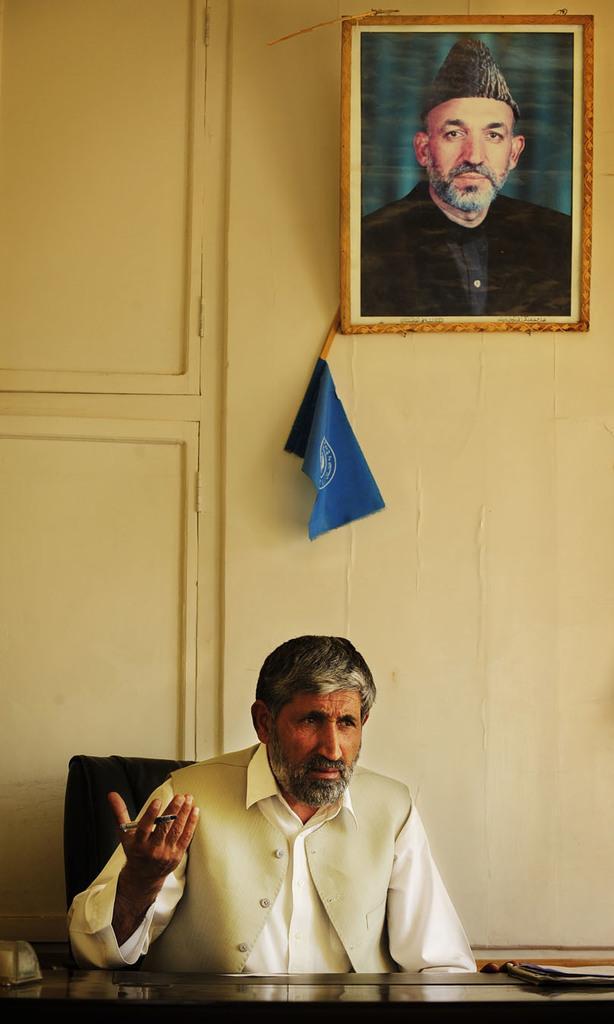Can you describe this image briefly? In this image we can see a man sitting on the chair by holding a pen in his hand and a table is placed in front of him. On the table we can see books. In the background we can see wall hanging on the wall and a flag. 